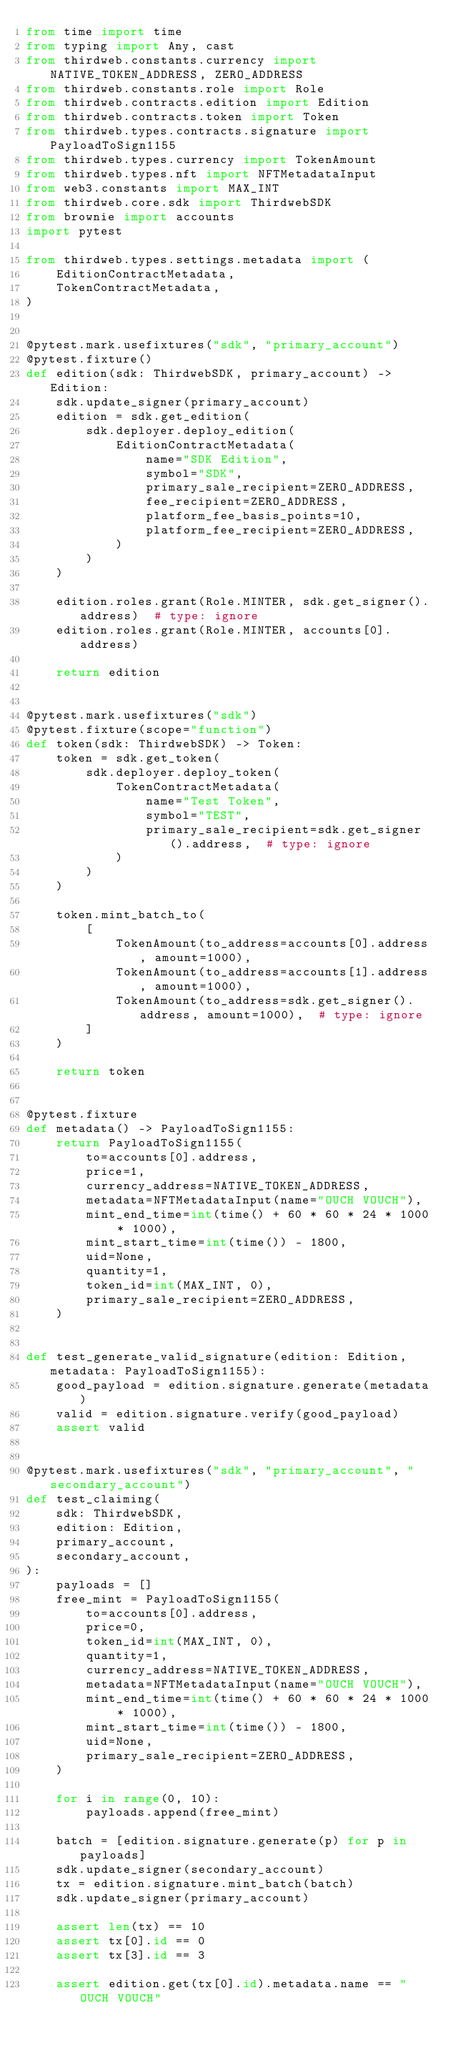Convert code to text. <code><loc_0><loc_0><loc_500><loc_500><_Python_>from time import time
from typing import Any, cast
from thirdweb.constants.currency import NATIVE_TOKEN_ADDRESS, ZERO_ADDRESS
from thirdweb.constants.role import Role
from thirdweb.contracts.edition import Edition
from thirdweb.contracts.token import Token
from thirdweb.types.contracts.signature import PayloadToSign1155
from thirdweb.types.currency import TokenAmount
from thirdweb.types.nft import NFTMetadataInput
from web3.constants import MAX_INT
from thirdweb.core.sdk import ThirdwebSDK
from brownie import accounts
import pytest

from thirdweb.types.settings.metadata import (
    EditionContractMetadata,
    TokenContractMetadata,
)


@pytest.mark.usefixtures("sdk", "primary_account")
@pytest.fixture()
def edition(sdk: ThirdwebSDK, primary_account) -> Edition:
    sdk.update_signer(primary_account)
    edition = sdk.get_edition(
        sdk.deployer.deploy_edition(
            EditionContractMetadata(
                name="SDK Edition",
                symbol="SDK",
                primary_sale_recipient=ZERO_ADDRESS,
                fee_recipient=ZERO_ADDRESS,
                platform_fee_basis_points=10,
                platform_fee_recipient=ZERO_ADDRESS,
            )
        )
    )

    edition.roles.grant(Role.MINTER, sdk.get_signer().address)  # type: ignore
    edition.roles.grant(Role.MINTER, accounts[0].address)

    return edition


@pytest.mark.usefixtures("sdk")
@pytest.fixture(scope="function")
def token(sdk: ThirdwebSDK) -> Token:
    token = sdk.get_token(
        sdk.deployer.deploy_token(
            TokenContractMetadata(
                name="Test Token",
                symbol="TEST",
                primary_sale_recipient=sdk.get_signer().address,  # type: ignore
            )
        )
    )

    token.mint_batch_to(
        [
            TokenAmount(to_address=accounts[0].address, amount=1000),
            TokenAmount(to_address=accounts[1].address, amount=1000),
            TokenAmount(to_address=sdk.get_signer().address, amount=1000),  # type: ignore
        ]
    )

    return token


@pytest.fixture
def metadata() -> PayloadToSign1155:
    return PayloadToSign1155(
        to=accounts[0].address,
        price=1,
        currency_address=NATIVE_TOKEN_ADDRESS,
        metadata=NFTMetadataInput(name="OUCH VOUCH"),
        mint_end_time=int(time() + 60 * 60 * 24 * 1000 * 1000),
        mint_start_time=int(time()) - 1800,
        uid=None,
        quantity=1,
        token_id=int(MAX_INT, 0),
        primary_sale_recipient=ZERO_ADDRESS,
    )


def test_generate_valid_signature(edition: Edition, metadata: PayloadToSign1155):
    good_payload = edition.signature.generate(metadata)
    valid = edition.signature.verify(good_payload)
    assert valid


@pytest.mark.usefixtures("sdk", "primary_account", "secondary_account")
def test_claiming(
    sdk: ThirdwebSDK,
    edition: Edition,
    primary_account,
    secondary_account,
):
    payloads = []
    free_mint = PayloadToSign1155(
        to=accounts[0].address,
        price=0,
        token_id=int(MAX_INT, 0),
        quantity=1,
        currency_address=NATIVE_TOKEN_ADDRESS,
        metadata=NFTMetadataInput(name="OUCH VOUCH"),
        mint_end_time=int(time() + 60 * 60 * 24 * 1000 * 1000),
        mint_start_time=int(time()) - 1800,
        uid=None,
        primary_sale_recipient=ZERO_ADDRESS,
    )

    for i in range(0, 10):
        payloads.append(free_mint)

    batch = [edition.signature.generate(p) for p in payloads]
    sdk.update_signer(secondary_account)
    tx = edition.signature.mint_batch(batch)
    sdk.update_signer(primary_account)

    assert len(tx) == 10
    assert tx[0].id == 0
    assert tx[3].id == 3

    assert edition.get(tx[0].id).metadata.name == "OUCH VOUCH"
</code> 